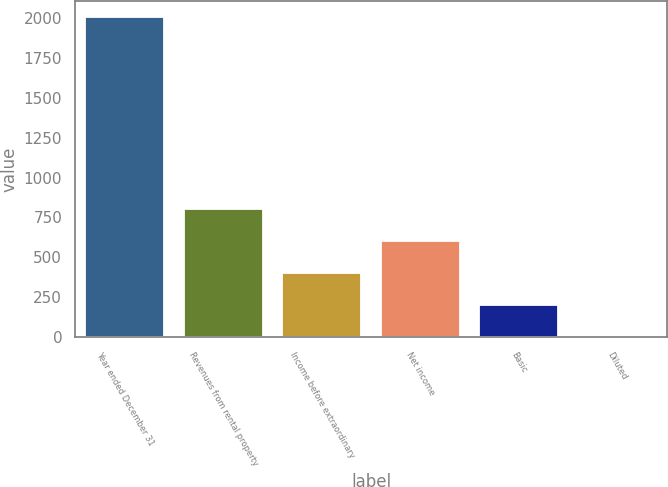Convert chart. <chart><loc_0><loc_0><loc_500><loc_500><bar_chart><fcel>Year ended December 31<fcel>Revenues from rental property<fcel>Income before extraordinary<fcel>Net income<fcel>Basic<fcel>Diluted<nl><fcel>2007<fcel>803.56<fcel>402.42<fcel>602.99<fcel>201.85<fcel>1.28<nl></chart> 